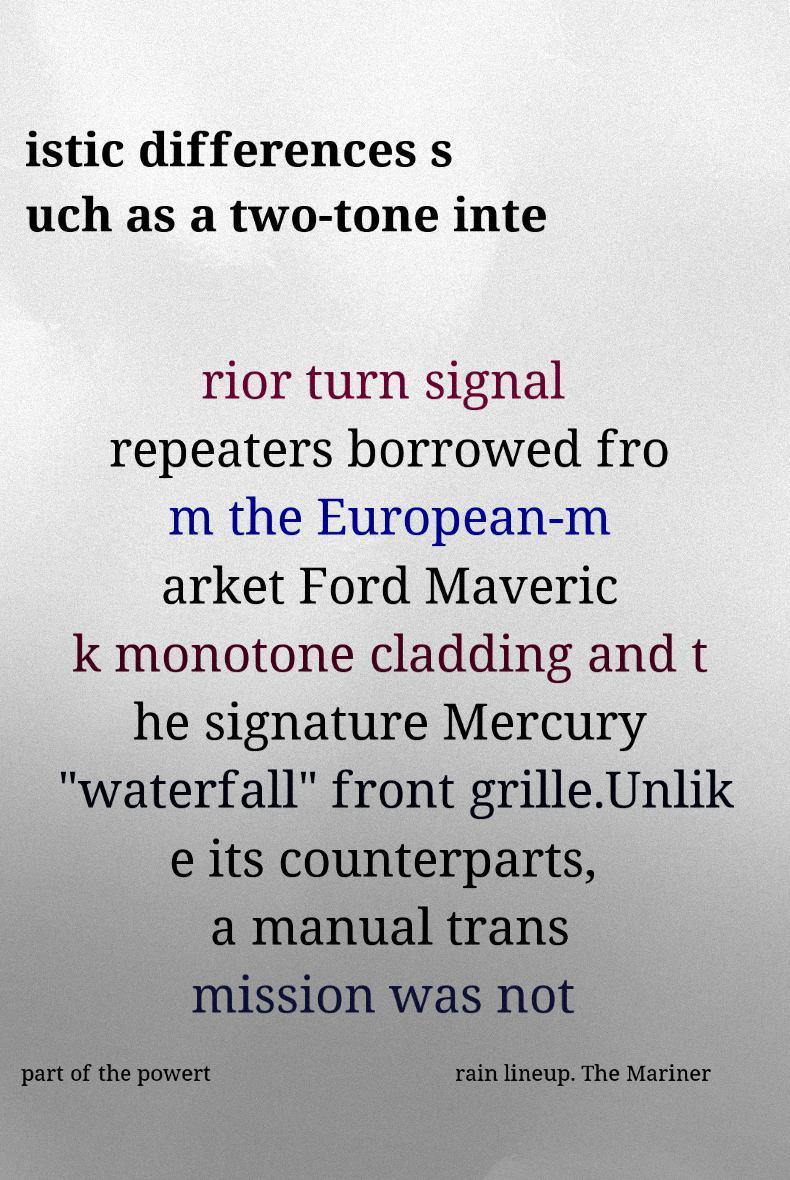Could you assist in decoding the text presented in this image and type it out clearly? istic differences s uch as a two-tone inte rior turn signal repeaters borrowed fro m the European-m arket Ford Maveric k monotone cladding and t he signature Mercury "waterfall" front grille.Unlik e its counterparts, a manual trans mission was not part of the powert rain lineup. The Mariner 